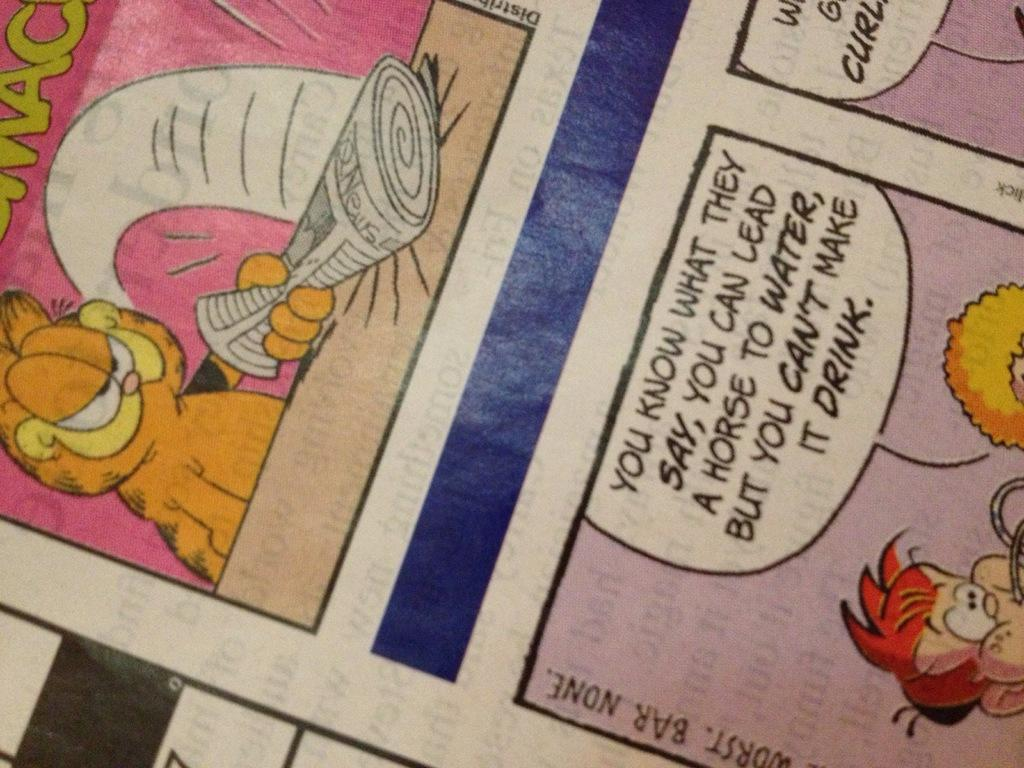What is present in the image that contains drawings? There is a paper in the image that contains cartoons. What else can be found on the paper besides cartoons? The paper contains text as well. What type of fork is being used to eat the cartoons on the paper? There is no fork present in the image, and cartoons cannot be eaten. 